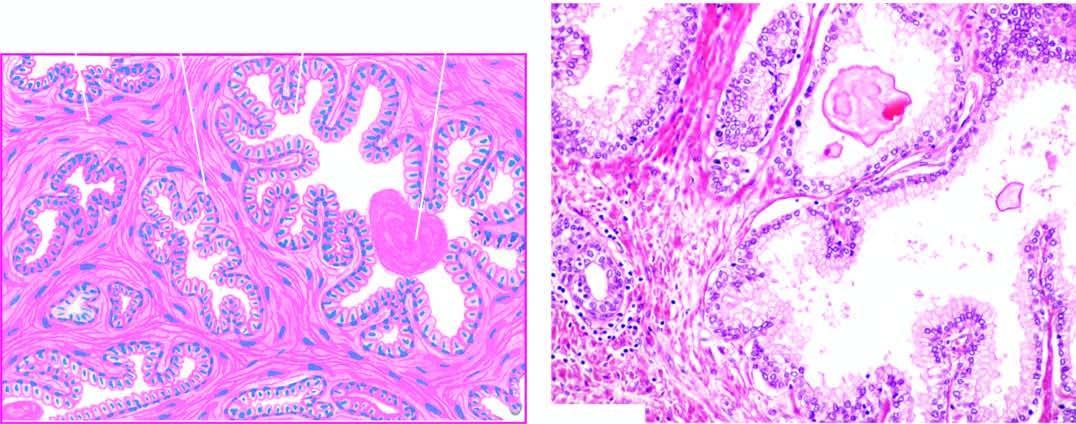s there hyperplasia of fibromuscular elements?
Answer the question using a single word or phrase. Yes 